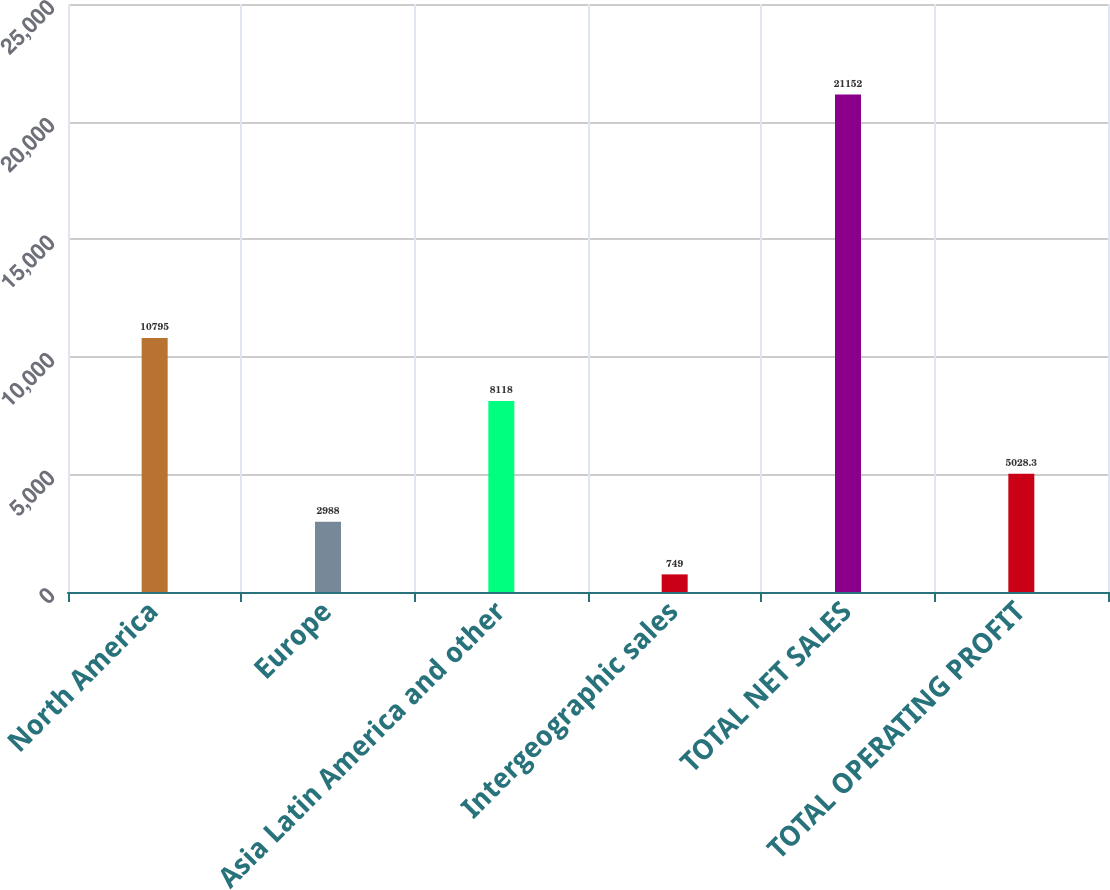<chart> <loc_0><loc_0><loc_500><loc_500><bar_chart><fcel>North America<fcel>Europe<fcel>Asia Latin America and other<fcel>Intergeographic sales<fcel>TOTAL NET SALES<fcel>TOTAL OPERATING PROFIT<nl><fcel>10795<fcel>2988<fcel>8118<fcel>749<fcel>21152<fcel>5028.3<nl></chart> 